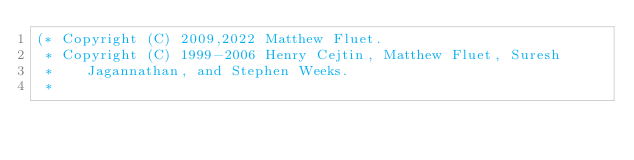<code> <loc_0><loc_0><loc_500><loc_500><_SML_>(* Copyright (C) 2009,2022 Matthew Fluet.
 * Copyright (C) 1999-2006 Henry Cejtin, Matthew Fluet, Suresh
 *    Jagannathan, and Stephen Weeks.
 *</code> 